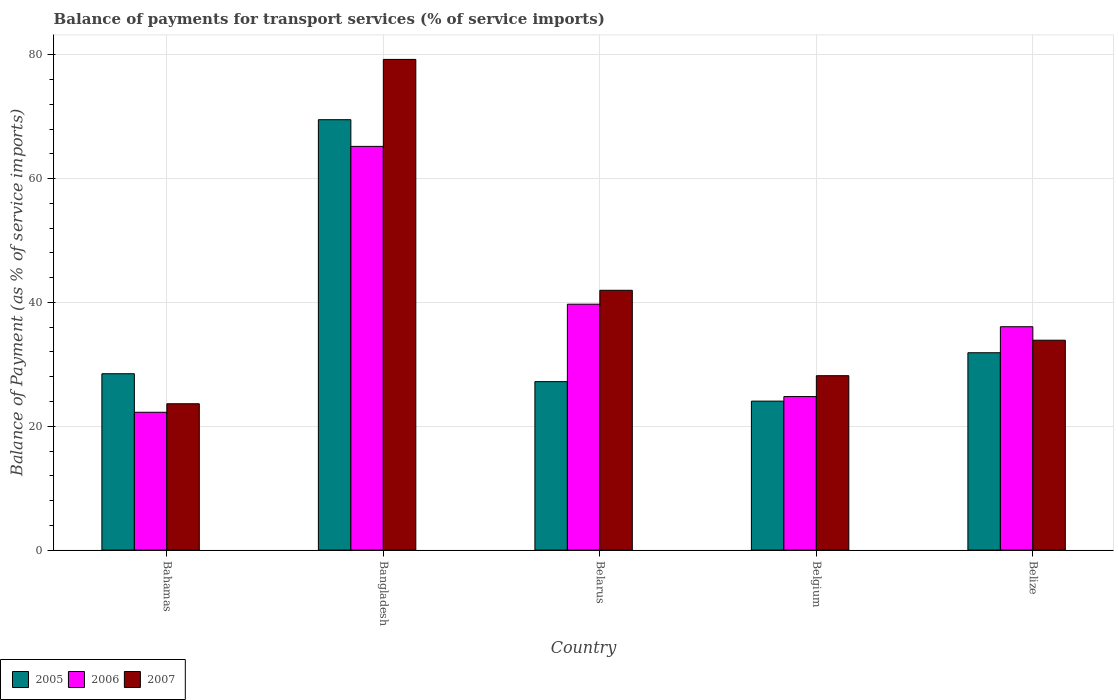How many groups of bars are there?
Your answer should be very brief. 5. Are the number of bars on each tick of the X-axis equal?
Ensure brevity in your answer.  Yes. How many bars are there on the 1st tick from the left?
Keep it short and to the point. 3. How many bars are there on the 3rd tick from the right?
Your answer should be very brief. 3. What is the label of the 3rd group of bars from the left?
Make the answer very short. Belarus. What is the balance of payments for transport services in 2006 in Bahamas?
Your response must be concise. 22.26. Across all countries, what is the maximum balance of payments for transport services in 2005?
Ensure brevity in your answer.  69.5. Across all countries, what is the minimum balance of payments for transport services in 2005?
Provide a short and direct response. 24.06. In which country was the balance of payments for transport services in 2006 minimum?
Ensure brevity in your answer.  Bahamas. What is the total balance of payments for transport services in 2007 in the graph?
Provide a succinct answer. 206.89. What is the difference between the balance of payments for transport services in 2006 in Bahamas and that in Belize?
Offer a very short reply. -13.82. What is the difference between the balance of payments for transport services in 2007 in Belgium and the balance of payments for transport services in 2006 in Bahamas?
Provide a succinct answer. 5.91. What is the average balance of payments for transport services in 2007 per country?
Provide a short and direct response. 41.38. What is the difference between the balance of payments for transport services of/in 2006 and balance of payments for transport services of/in 2007 in Bangladesh?
Your answer should be very brief. -14.04. In how many countries, is the balance of payments for transport services in 2005 greater than 8 %?
Offer a very short reply. 5. What is the ratio of the balance of payments for transport services in 2006 in Bahamas to that in Belgium?
Your response must be concise. 0.9. Is the balance of payments for transport services in 2005 in Belarus less than that in Belize?
Keep it short and to the point. Yes. Is the difference between the balance of payments for transport services in 2006 in Bahamas and Bangladesh greater than the difference between the balance of payments for transport services in 2007 in Bahamas and Bangladesh?
Make the answer very short. Yes. What is the difference between the highest and the second highest balance of payments for transport services in 2006?
Offer a very short reply. 29.12. What is the difference between the highest and the lowest balance of payments for transport services in 2007?
Give a very brief answer. 55.61. In how many countries, is the balance of payments for transport services in 2005 greater than the average balance of payments for transport services in 2005 taken over all countries?
Give a very brief answer. 1. Is it the case that in every country, the sum of the balance of payments for transport services in 2005 and balance of payments for transport services in 2006 is greater than the balance of payments for transport services in 2007?
Ensure brevity in your answer.  Yes. How many bars are there?
Provide a short and direct response. 15. Are all the bars in the graph horizontal?
Your answer should be compact. No. Does the graph contain any zero values?
Give a very brief answer. No. Does the graph contain grids?
Offer a very short reply. Yes. How many legend labels are there?
Give a very brief answer. 3. What is the title of the graph?
Your answer should be compact. Balance of payments for transport services (% of service imports). Does "1985" appear as one of the legend labels in the graph?
Provide a short and direct response. No. What is the label or title of the X-axis?
Ensure brevity in your answer.  Country. What is the label or title of the Y-axis?
Ensure brevity in your answer.  Balance of Payment (as % of service imports). What is the Balance of Payment (as % of service imports) of 2005 in Bahamas?
Offer a very short reply. 28.48. What is the Balance of Payment (as % of service imports) of 2006 in Bahamas?
Your answer should be very brief. 22.26. What is the Balance of Payment (as % of service imports) of 2007 in Bahamas?
Give a very brief answer. 23.63. What is the Balance of Payment (as % of service imports) in 2005 in Bangladesh?
Provide a short and direct response. 69.5. What is the Balance of Payment (as % of service imports) in 2006 in Bangladesh?
Provide a short and direct response. 65.2. What is the Balance of Payment (as % of service imports) of 2007 in Bangladesh?
Your answer should be very brief. 79.24. What is the Balance of Payment (as % of service imports) in 2005 in Belarus?
Your answer should be compact. 27.2. What is the Balance of Payment (as % of service imports) in 2006 in Belarus?
Offer a very short reply. 39.71. What is the Balance of Payment (as % of service imports) of 2007 in Belarus?
Your answer should be very brief. 41.96. What is the Balance of Payment (as % of service imports) in 2005 in Belgium?
Provide a succinct answer. 24.06. What is the Balance of Payment (as % of service imports) in 2006 in Belgium?
Your answer should be compact. 24.79. What is the Balance of Payment (as % of service imports) of 2007 in Belgium?
Your answer should be compact. 28.16. What is the Balance of Payment (as % of service imports) of 2005 in Belize?
Provide a succinct answer. 31.87. What is the Balance of Payment (as % of service imports) of 2006 in Belize?
Your answer should be very brief. 36.07. What is the Balance of Payment (as % of service imports) in 2007 in Belize?
Keep it short and to the point. 33.89. Across all countries, what is the maximum Balance of Payment (as % of service imports) of 2005?
Make the answer very short. 69.5. Across all countries, what is the maximum Balance of Payment (as % of service imports) in 2006?
Ensure brevity in your answer.  65.2. Across all countries, what is the maximum Balance of Payment (as % of service imports) of 2007?
Your answer should be very brief. 79.24. Across all countries, what is the minimum Balance of Payment (as % of service imports) in 2005?
Offer a very short reply. 24.06. Across all countries, what is the minimum Balance of Payment (as % of service imports) in 2006?
Make the answer very short. 22.26. Across all countries, what is the minimum Balance of Payment (as % of service imports) in 2007?
Provide a succinct answer. 23.63. What is the total Balance of Payment (as % of service imports) of 2005 in the graph?
Ensure brevity in your answer.  181.12. What is the total Balance of Payment (as % of service imports) of 2006 in the graph?
Make the answer very short. 188.03. What is the total Balance of Payment (as % of service imports) in 2007 in the graph?
Keep it short and to the point. 206.89. What is the difference between the Balance of Payment (as % of service imports) in 2005 in Bahamas and that in Bangladesh?
Make the answer very short. -41.02. What is the difference between the Balance of Payment (as % of service imports) in 2006 in Bahamas and that in Bangladesh?
Your response must be concise. -42.94. What is the difference between the Balance of Payment (as % of service imports) in 2007 in Bahamas and that in Bangladesh?
Your answer should be compact. -55.61. What is the difference between the Balance of Payment (as % of service imports) in 2005 in Bahamas and that in Belarus?
Keep it short and to the point. 1.28. What is the difference between the Balance of Payment (as % of service imports) of 2006 in Bahamas and that in Belarus?
Your response must be concise. -17.45. What is the difference between the Balance of Payment (as % of service imports) of 2007 in Bahamas and that in Belarus?
Offer a very short reply. -18.32. What is the difference between the Balance of Payment (as % of service imports) of 2005 in Bahamas and that in Belgium?
Give a very brief answer. 4.42. What is the difference between the Balance of Payment (as % of service imports) of 2006 in Bahamas and that in Belgium?
Your response must be concise. -2.54. What is the difference between the Balance of Payment (as % of service imports) of 2007 in Bahamas and that in Belgium?
Offer a very short reply. -4.53. What is the difference between the Balance of Payment (as % of service imports) of 2005 in Bahamas and that in Belize?
Ensure brevity in your answer.  -3.39. What is the difference between the Balance of Payment (as % of service imports) in 2006 in Bahamas and that in Belize?
Keep it short and to the point. -13.82. What is the difference between the Balance of Payment (as % of service imports) of 2007 in Bahamas and that in Belize?
Keep it short and to the point. -10.26. What is the difference between the Balance of Payment (as % of service imports) in 2005 in Bangladesh and that in Belarus?
Provide a succinct answer. 42.3. What is the difference between the Balance of Payment (as % of service imports) in 2006 in Bangladesh and that in Belarus?
Your answer should be compact. 25.48. What is the difference between the Balance of Payment (as % of service imports) of 2007 in Bangladesh and that in Belarus?
Offer a terse response. 37.28. What is the difference between the Balance of Payment (as % of service imports) of 2005 in Bangladesh and that in Belgium?
Your response must be concise. 45.45. What is the difference between the Balance of Payment (as % of service imports) in 2006 in Bangladesh and that in Belgium?
Provide a short and direct response. 40.4. What is the difference between the Balance of Payment (as % of service imports) in 2007 in Bangladesh and that in Belgium?
Give a very brief answer. 51.08. What is the difference between the Balance of Payment (as % of service imports) of 2005 in Bangladesh and that in Belize?
Keep it short and to the point. 37.63. What is the difference between the Balance of Payment (as % of service imports) in 2006 in Bangladesh and that in Belize?
Make the answer very short. 29.12. What is the difference between the Balance of Payment (as % of service imports) of 2007 in Bangladesh and that in Belize?
Offer a terse response. 45.35. What is the difference between the Balance of Payment (as % of service imports) of 2005 in Belarus and that in Belgium?
Give a very brief answer. 3.15. What is the difference between the Balance of Payment (as % of service imports) of 2006 in Belarus and that in Belgium?
Ensure brevity in your answer.  14.92. What is the difference between the Balance of Payment (as % of service imports) of 2007 in Belarus and that in Belgium?
Your answer should be very brief. 13.79. What is the difference between the Balance of Payment (as % of service imports) in 2005 in Belarus and that in Belize?
Your response must be concise. -4.67. What is the difference between the Balance of Payment (as % of service imports) of 2006 in Belarus and that in Belize?
Offer a terse response. 3.64. What is the difference between the Balance of Payment (as % of service imports) of 2007 in Belarus and that in Belize?
Give a very brief answer. 8.06. What is the difference between the Balance of Payment (as % of service imports) of 2005 in Belgium and that in Belize?
Provide a succinct answer. -7.81. What is the difference between the Balance of Payment (as % of service imports) in 2006 in Belgium and that in Belize?
Keep it short and to the point. -11.28. What is the difference between the Balance of Payment (as % of service imports) of 2007 in Belgium and that in Belize?
Your response must be concise. -5.73. What is the difference between the Balance of Payment (as % of service imports) of 2005 in Bahamas and the Balance of Payment (as % of service imports) of 2006 in Bangladesh?
Give a very brief answer. -36.71. What is the difference between the Balance of Payment (as % of service imports) in 2005 in Bahamas and the Balance of Payment (as % of service imports) in 2007 in Bangladesh?
Provide a short and direct response. -50.76. What is the difference between the Balance of Payment (as % of service imports) in 2006 in Bahamas and the Balance of Payment (as % of service imports) in 2007 in Bangladesh?
Ensure brevity in your answer.  -56.98. What is the difference between the Balance of Payment (as % of service imports) of 2005 in Bahamas and the Balance of Payment (as % of service imports) of 2006 in Belarus?
Provide a short and direct response. -11.23. What is the difference between the Balance of Payment (as % of service imports) of 2005 in Bahamas and the Balance of Payment (as % of service imports) of 2007 in Belarus?
Offer a very short reply. -13.47. What is the difference between the Balance of Payment (as % of service imports) in 2006 in Bahamas and the Balance of Payment (as % of service imports) in 2007 in Belarus?
Make the answer very short. -19.7. What is the difference between the Balance of Payment (as % of service imports) in 2005 in Bahamas and the Balance of Payment (as % of service imports) in 2006 in Belgium?
Provide a succinct answer. 3.69. What is the difference between the Balance of Payment (as % of service imports) in 2005 in Bahamas and the Balance of Payment (as % of service imports) in 2007 in Belgium?
Ensure brevity in your answer.  0.32. What is the difference between the Balance of Payment (as % of service imports) of 2006 in Bahamas and the Balance of Payment (as % of service imports) of 2007 in Belgium?
Ensure brevity in your answer.  -5.91. What is the difference between the Balance of Payment (as % of service imports) of 2005 in Bahamas and the Balance of Payment (as % of service imports) of 2006 in Belize?
Your response must be concise. -7.59. What is the difference between the Balance of Payment (as % of service imports) in 2005 in Bahamas and the Balance of Payment (as % of service imports) in 2007 in Belize?
Offer a very short reply. -5.41. What is the difference between the Balance of Payment (as % of service imports) in 2006 in Bahamas and the Balance of Payment (as % of service imports) in 2007 in Belize?
Your answer should be compact. -11.64. What is the difference between the Balance of Payment (as % of service imports) of 2005 in Bangladesh and the Balance of Payment (as % of service imports) of 2006 in Belarus?
Provide a succinct answer. 29.79. What is the difference between the Balance of Payment (as % of service imports) in 2005 in Bangladesh and the Balance of Payment (as % of service imports) in 2007 in Belarus?
Keep it short and to the point. 27.55. What is the difference between the Balance of Payment (as % of service imports) of 2006 in Bangladesh and the Balance of Payment (as % of service imports) of 2007 in Belarus?
Your answer should be compact. 23.24. What is the difference between the Balance of Payment (as % of service imports) in 2005 in Bangladesh and the Balance of Payment (as % of service imports) in 2006 in Belgium?
Your answer should be very brief. 44.71. What is the difference between the Balance of Payment (as % of service imports) in 2005 in Bangladesh and the Balance of Payment (as % of service imports) in 2007 in Belgium?
Provide a short and direct response. 41.34. What is the difference between the Balance of Payment (as % of service imports) in 2006 in Bangladesh and the Balance of Payment (as % of service imports) in 2007 in Belgium?
Offer a terse response. 37.03. What is the difference between the Balance of Payment (as % of service imports) of 2005 in Bangladesh and the Balance of Payment (as % of service imports) of 2006 in Belize?
Ensure brevity in your answer.  33.43. What is the difference between the Balance of Payment (as % of service imports) in 2005 in Bangladesh and the Balance of Payment (as % of service imports) in 2007 in Belize?
Provide a short and direct response. 35.61. What is the difference between the Balance of Payment (as % of service imports) in 2006 in Bangladesh and the Balance of Payment (as % of service imports) in 2007 in Belize?
Your response must be concise. 31.3. What is the difference between the Balance of Payment (as % of service imports) in 2005 in Belarus and the Balance of Payment (as % of service imports) in 2006 in Belgium?
Your answer should be compact. 2.41. What is the difference between the Balance of Payment (as % of service imports) of 2005 in Belarus and the Balance of Payment (as % of service imports) of 2007 in Belgium?
Your response must be concise. -0.96. What is the difference between the Balance of Payment (as % of service imports) in 2006 in Belarus and the Balance of Payment (as % of service imports) in 2007 in Belgium?
Provide a succinct answer. 11.55. What is the difference between the Balance of Payment (as % of service imports) in 2005 in Belarus and the Balance of Payment (as % of service imports) in 2006 in Belize?
Your response must be concise. -8.87. What is the difference between the Balance of Payment (as % of service imports) in 2005 in Belarus and the Balance of Payment (as % of service imports) in 2007 in Belize?
Make the answer very short. -6.69. What is the difference between the Balance of Payment (as % of service imports) of 2006 in Belarus and the Balance of Payment (as % of service imports) of 2007 in Belize?
Your answer should be very brief. 5.82. What is the difference between the Balance of Payment (as % of service imports) in 2005 in Belgium and the Balance of Payment (as % of service imports) in 2006 in Belize?
Offer a very short reply. -12.02. What is the difference between the Balance of Payment (as % of service imports) in 2005 in Belgium and the Balance of Payment (as % of service imports) in 2007 in Belize?
Provide a short and direct response. -9.84. What is the difference between the Balance of Payment (as % of service imports) of 2006 in Belgium and the Balance of Payment (as % of service imports) of 2007 in Belize?
Provide a short and direct response. -9.1. What is the average Balance of Payment (as % of service imports) of 2005 per country?
Give a very brief answer. 36.22. What is the average Balance of Payment (as % of service imports) of 2006 per country?
Give a very brief answer. 37.61. What is the average Balance of Payment (as % of service imports) of 2007 per country?
Ensure brevity in your answer.  41.38. What is the difference between the Balance of Payment (as % of service imports) of 2005 and Balance of Payment (as % of service imports) of 2006 in Bahamas?
Keep it short and to the point. 6.22. What is the difference between the Balance of Payment (as % of service imports) in 2005 and Balance of Payment (as % of service imports) in 2007 in Bahamas?
Keep it short and to the point. 4.85. What is the difference between the Balance of Payment (as % of service imports) of 2006 and Balance of Payment (as % of service imports) of 2007 in Bahamas?
Ensure brevity in your answer.  -1.37. What is the difference between the Balance of Payment (as % of service imports) of 2005 and Balance of Payment (as % of service imports) of 2006 in Bangladesh?
Make the answer very short. 4.31. What is the difference between the Balance of Payment (as % of service imports) of 2005 and Balance of Payment (as % of service imports) of 2007 in Bangladesh?
Offer a very short reply. -9.74. What is the difference between the Balance of Payment (as % of service imports) in 2006 and Balance of Payment (as % of service imports) in 2007 in Bangladesh?
Make the answer very short. -14.04. What is the difference between the Balance of Payment (as % of service imports) of 2005 and Balance of Payment (as % of service imports) of 2006 in Belarus?
Your response must be concise. -12.51. What is the difference between the Balance of Payment (as % of service imports) of 2005 and Balance of Payment (as % of service imports) of 2007 in Belarus?
Offer a very short reply. -14.75. What is the difference between the Balance of Payment (as % of service imports) in 2006 and Balance of Payment (as % of service imports) in 2007 in Belarus?
Provide a succinct answer. -2.24. What is the difference between the Balance of Payment (as % of service imports) of 2005 and Balance of Payment (as % of service imports) of 2006 in Belgium?
Make the answer very short. -0.74. What is the difference between the Balance of Payment (as % of service imports) in 2005 and Balance of Payment (as % of service imports) in 2007 in Belgium?
Offer a terse response. -4.11. What is the difference between the Balance of Payment (as % of service imports) in 2006 and Balance of Payment (as % of service imports) in 2007 in Belgium?
Offer a very short reply. -3.37. What is the difference between the Balance of Payment (as % of service imports) in 2005 and Balance of Payment (as % of service imports) in 2006 in Belize?
Provide a short and direct response. -4.2. What is the difference between the Balance of Payment (as % of service imports) of 2005 and Balance of Payment (as % of service imports) of 2007 in Belize?
Keep it short and to the point. -2.02. What is the difference between the Balance of Payment (as % of service imports) in 2006 and Balance of Payment (as % of service imports) in 2007 in Belize?
Give a very brief answer. 2.18. What is the ratio of the Balance of Payment (as % of service imports) in 2005 in Bahamas to that in Bangladesh?
Your answer should be compact. 0.41. What is the ratio of the Balance of Payment (as % of service imports) in 2006 in Bahamas to that in Bangladesh?
Ensure brevity in your answer.  0.34. What is the ratio of the Balance of Payment (as % of service imports) of 2007 in Bahamas to that in Bangladesh?
Provide a succinct answer. 0.3. What is the ratio of the Balance of Payment (as % of service imports) in 2005 in Bahamas to that in Belarus?
Your response must be concise. 1.05. What is the ratio of the Balance of Payment (as % of service imports) of 2006 in Bahamas to that in Belarus?
Keep it short and to the point. 0.56. What is the ratio of the Balance of Payment (as % of service imports) in 2007 in Bahamas to that in Belarus?
Provide a succinct answer. 0.56. What is the ratio of the Balance of Payment (as % of service imports) in 2005 in Bahamas to that in Belgium?
Your answer should be compact. 1.18. What is the ratio of the Balance of Payment (as % of service imports) of 2006 in Bahamas to that in Belgium?
Give a very brief answer. 0.9. What is the ratio of the Balance of Payment (as % of service imports) in 2007 in Bahamas to that in Belgium?
Make the answer very short. 0.84. What is the ratio of the Balance of Payment (as % of service imports) in 2005 in Bahamas to that in Belize?
Your answer should be very brief. 0.89. What is the ratio of the Balance of Payment (as % of service imports) in 2006 in Bahamas to that in Belize?
Offer a terse response. 0.62. What is the ratio of the Balance of Payment (as % of service imports) in 2007 in Bahamas to that in Belize?
Give a very brief answer. 0.7. What is the ratio of the Balance of Payment (as % of service imports) of 2005 in Bangladesh to that in Belarus?
Provide a short and direct response. 2.55. What is the ratio of the Balance of Payment (as % of service imports) of 2006 in Bangladesh to that in Belarus?
Ensure brevity in your answer.  1.64. What is the ratio of the Balance of Payment (as % of service imports) of 2007 in Bangladesh to that in Belarus?
Your answer should be very brief. 1.89. What is the ratio of the Balance of Payment (as % of service imports) in 2005 in Bangladesh to that in Belgium?
Offer a very short reply. 2.89. What is the ratio of the Balance of Payment (as % of service imports) in 2006 in Bangladesh to that in Belgium?
Keep it short and to the point. 2.63. What is the ratio of the Balance of Payment (as % of service imports) in 2007 in Bangladesh to that in Belgium?
Provide a succinct answer. 2.81. What is the ratio of the Balance of Payment (as % of service imports) in 2005 in Bangladesh to that in Belize?
Keep it short and to the point. 2.18. What is the ratio of the Balance of Payment (as % of service imports) of 2006 in Bangladesh to that in Belize?
Provide a short and direct response. 1.81. What is the ratio of the Balance of Payment (as % of service imports) of 2007 in Bangladesh to that in Belize?
Keep it short and to the point. 2.34. What is the ratio of the Balance of Payment (as % of service imports) in 2005 in Belarus to that in Belgium?
Provide a short and direct response. 1.13. What is the ratio of the Balance of Payment (as % of service imports) in 2006 in Belarus to that in Belgium?
Your answer should be very brief. 1.6. What is the ratio of the Balance of Payment (as % of service imports) in 2007 in Belarus to that in Belgium?
Provide a short and direct response. 1.49. What is the ratio of the Balance of Payment (as % of service imports) in 2005 in Belarus to that in Belize?
Offer a very short reply. 0.85. What is the ratio of the Balance of Payment (as % of service imports) of 2006 in Belarus to that in Belize?
Provide a succinct answer. 1.1. What is the ratio of the Balance of Payment (as % of service imports) in 2007 in Belarus to that in Belize?
Keep it short and to the point. 1.24. What is the ratio of the Balance of Payment (as % of service imports) of 2005 in Belgium to that in Belize?
Give a very brief answer. 0.75. What is the ratio of the Balance of Payment (as % of service imports) in 2006 in Belgium to that in Belize?
Offer a very short reply. 0.69. What is the ratio of the Balance of Payment (as % of service imports) in 2007 in Belgium to that in Belize?
Keep it short and to the point. 0.83. What is the difference between the highest and the second highest Balance of Payment (as % of service imports) in 2005?
Provide a short and direct response. 37.63. What is the difference between the highest and the second highest Balance of Payment (as % of service imports) in 2006?
Offer a very short reply. 25.48. What is the difference between the highest and the second highest Balance of Payment (as % of service imports) in 2007?
Make the answer very short. 37.28. What is the difference between the highest and the lowest Balance of Payment (as % of service imports) of 2005?
Provide a short and direct response. 45.45. What is the difference between the highest and the lowest Balance of Payment (as % of service imports) in 2006?
Offer a very short reply. 42.94. What is the difference between the highest and the lowest Balance of Payment (as % of service imports) of 2007?
Ensure brevity in your answer.  55.61. 